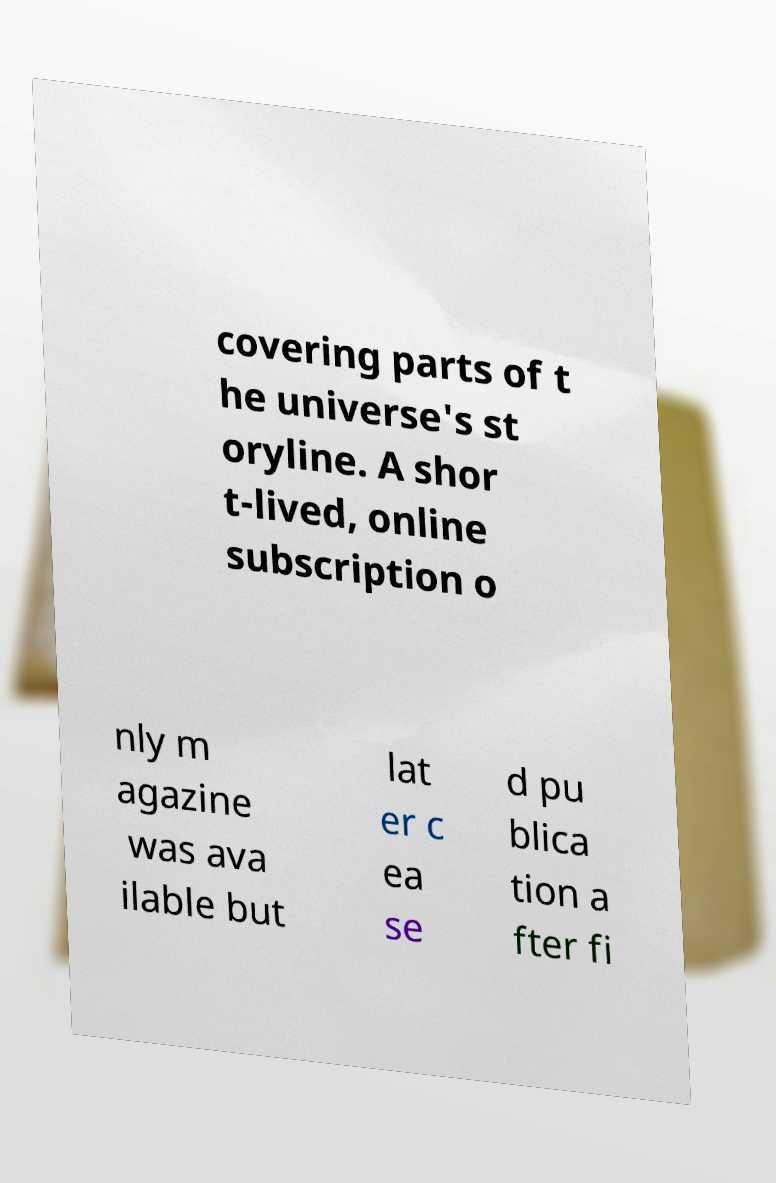Could you assist in decoding the text presented in this image and type it out clearly? covering parts of t he universe's st oryline. A shor t-lived, online subscription o nly m agazine was ava ilable but lat er c ea se d pu blica tion a fter fi 